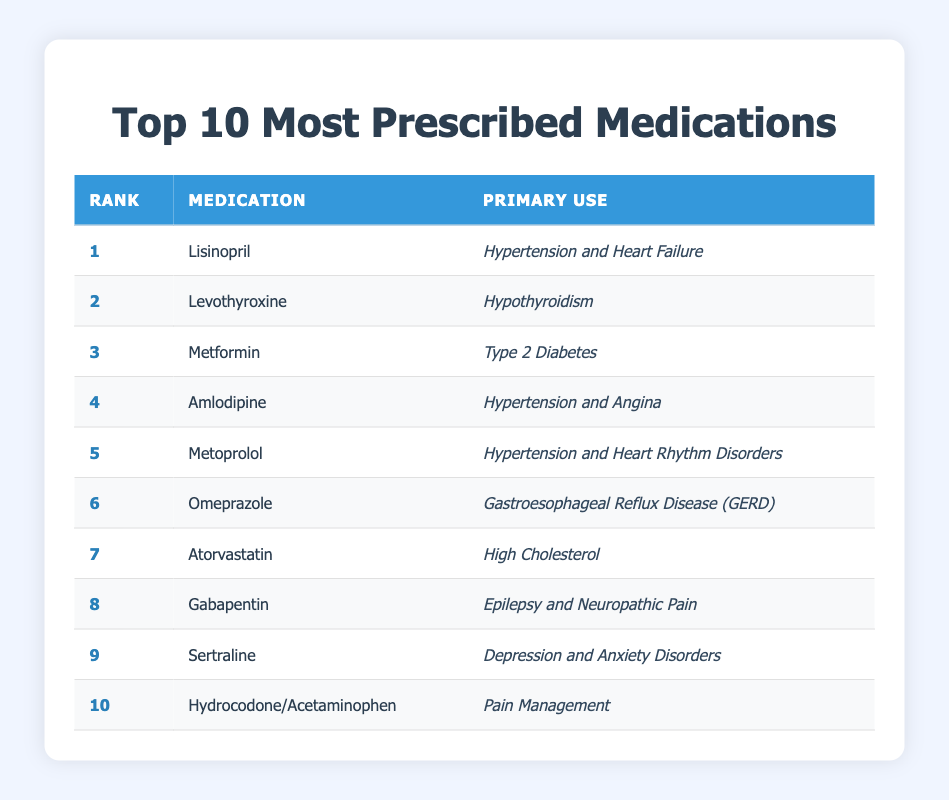What is the primary use of Lisinopril? Lisinopril is listed in the table as having the primary use of hypertension and heart failure.
Answer: Hypertension and heart failure Which medication is used to manage Type 2 Diabetes? The table states that Metformin is the medication used for Type 2 Diabetes.
Answer: Metformin True or False: Atorvastatin is prescribed for pain management. The table shows that Atorvastatin's primary use is high cholesterol, so it is not for pain management.
Answer: False How many medications in the list are used for hypertension? The table lists Lisinopril, Amlodipine, and Metoprolol as medications for hypertension, totaling three.
Answer: Three Which medication ranked 8th and what are its primary uses? The table indicates that Gabapentin is ranked 8th and is used for epilepsy and neuropathic pain.
Answer: Gabapentin; epilepsy and neuropathic pain What is the difference in rank between Levothyroxine and Metoprolol? Levothyroxine is ranked 2nd and Metoprolol is ranked 5th, so the difference in their ranks is 5 - 2 = 3.
Answer: 3 Identify the medication primarily used for depression and anxiety disorders. According to the table, Sertraline is the medication primarily used for depression and anxiety disorders.
Answer: Sertraline True or False: Omeprazole is primarily used for hypertension. The table lists Omeprazole's primary use as gastroesophageal reflux disease (GERD), not hypertension, making the statement false.
Answer: False How many medications on the list treat heart-related issues? The table shows Lisinopril, Amlodipine, and Metoprolol as treating heart-related issues such as hypertension and heart failure or rhythm disorders, totaling three medications.
Answer: Three 